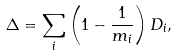Convert formula to latex. <formula><loc_0><loc_0><loc_500><loc_500>\Delta = \sum _ { i } \left ( 1 - \frac { 1 } { m _ { i } } \right ) D _ { i } ,</formula> 